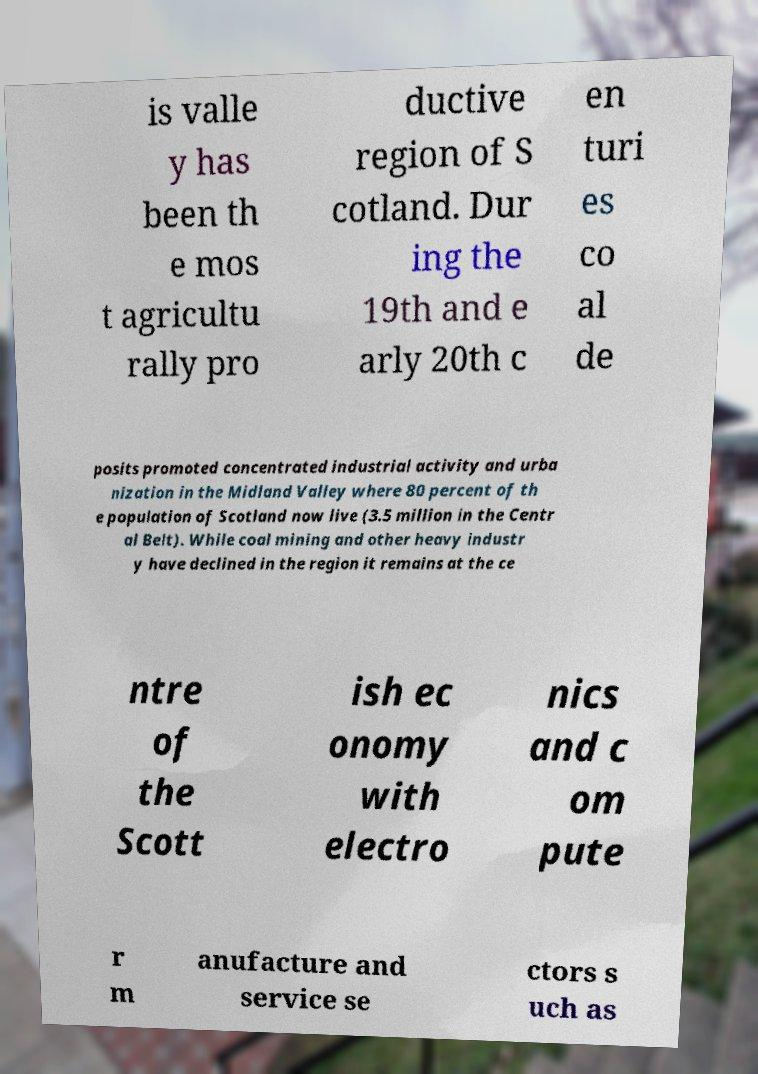There's text embedded in this image that I need extracted. Can you transcribe it verbatim? is valle y has been th e mos t agricultu rally pro ductive region of S cotland. Dur ing the 19th and e arly 20th c en turi es co al de posits promoted concentrated industrial activity and urba nization in the Midland Valley where 80 percent of th e population of Scotland now live (3.5 million in the Centr al Belt). While coal mining and other heavy industr y have declined in the region it remains at the ce ntre of the Scott ish ec onomy with electro nics and c om pute r m anufacture and service se ctors s uch as 